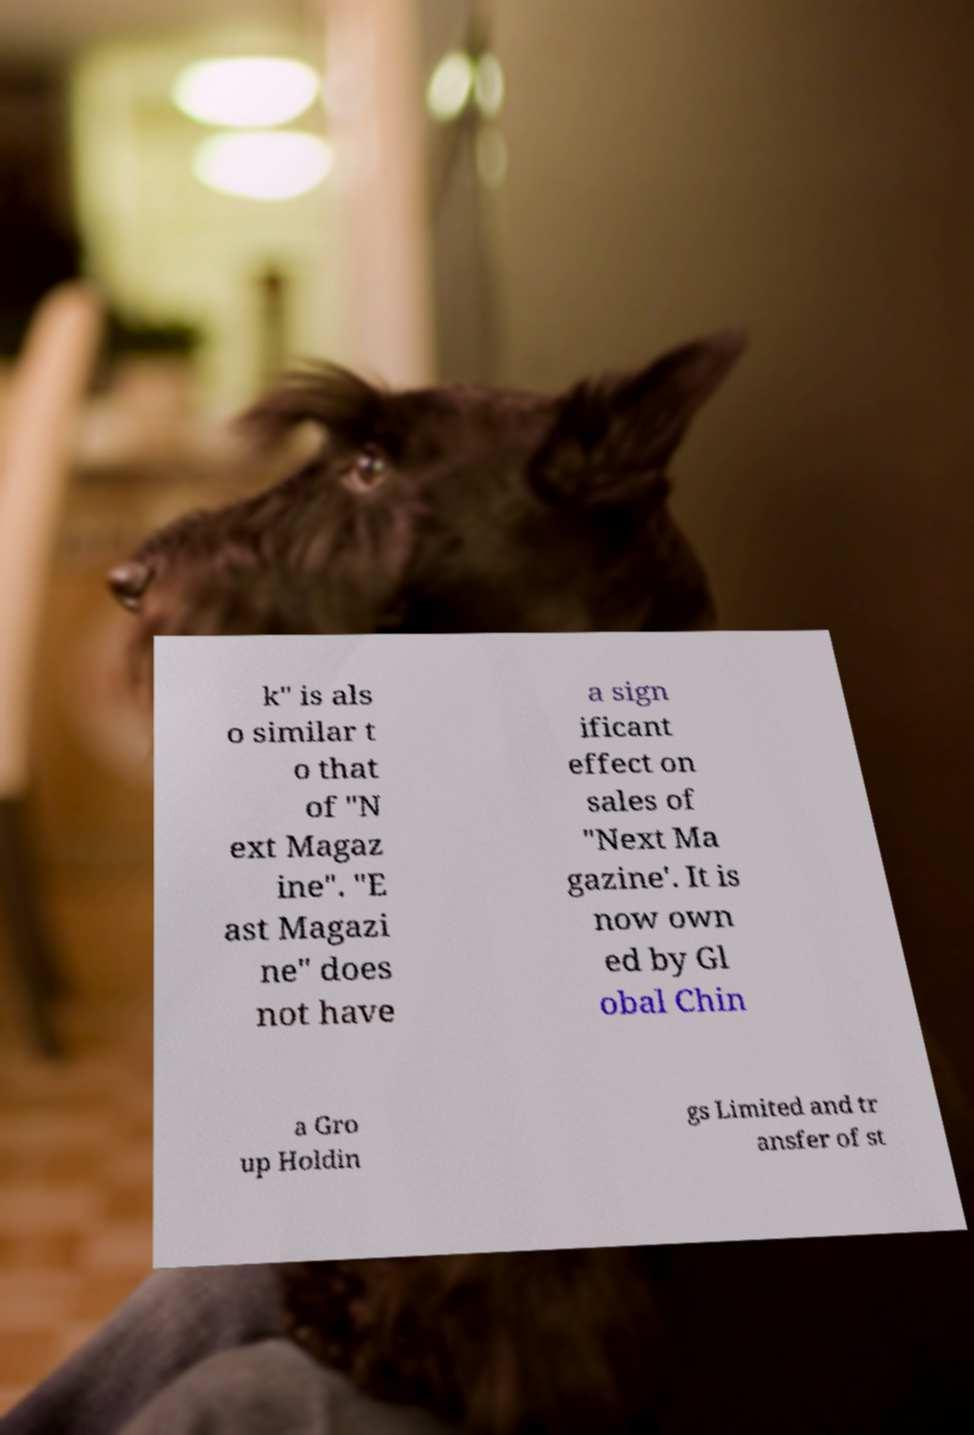There's text embedded in this image that I need extracted. Can you transcribe it verbatim? k" is als o similar t o that of "N ext Magaz ine". "E ast Magazi ne" does not have a sign ificant effect on sales of "Next Ma gazine'. It is now own ed by Gl obal Chin a Gro up Holdin gs Limited and tr ansfer of st 